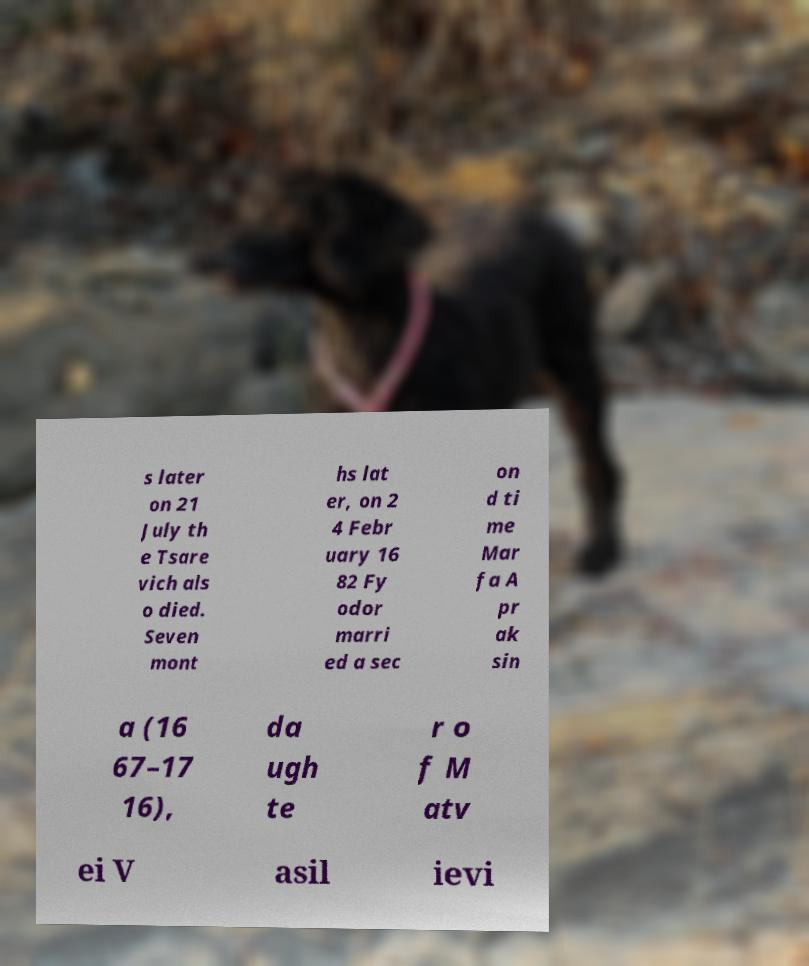I need the written content from this picture converted into text. Can you do that? s later on 21 July th e Tsare vich als o died. Seven mont hs lat er, on 2 4 Febr uary 16 82 Fy odor marri ed a sec on d ti me Mar fa A pr ak sin a (16 67–17 16), da ugh te r o f M atv ei V asil ievi 